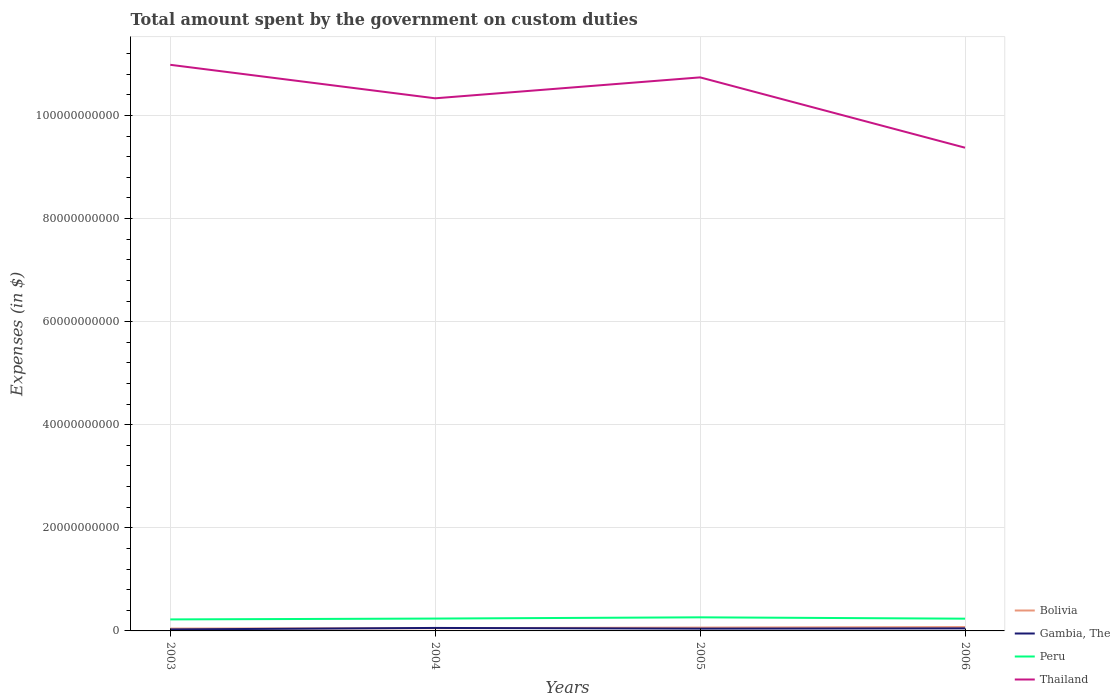How many different coloured lines are there?
Offer a very short reply. 4. Does the line corresponding to Thailand intersect with the line corresponding to Gambia, The?
Your answer should be compact. No. Is the number of lines equal to the number of legend labels?
Offer a terse response. Yes. Across all years, what is the maximum amount spent on custom duties by the government in Thailand?
Your response must be concise. 9.37e+1. In which year was the amount spent on custom duties by the government in Thailand maximum?
Offer a terse response. 2006. What is the total amount spent on custom duties by the government in Gambia, The in the graph?
Provide a succinct answer. -4.74e+07. What is the difference between the highest and the second highest amount spent on custom duties by the government in Gambia, The?
Offer a very short reply. 2.86e+08. What is the difference between the highest and the lowest amount spent on custom duties by the government in Peru?
Ensure brevity in your answer.  1. Where does the legend appear in the graph?
Your answer should be compact. Bottom right. What is the title of the graph?
Your response must be concise. Total amount spent by the government on custom duties. Does "Sub-Saharan Africa (developing only)" appear as one of the legend labels in the graph?
Offer a terse response. No. What is the label or title of the X-axis?
Keep it short and to the point. Years. What is the label or title of the Y-axis?
Give a very brief answer. Expenses (in $). What is the Expenses (in $) in Bolivia in 2003?
Your answer should be compact. 4.55e+08. What is the Expenses (in $) of Gambia, The in 2003?
Make the answer very short. 2.92e+08. What is the Expenses (in $) in Peru in 2003?
Keep it short and to the point. 2.23e+09. What is the Expenses (in $) in Thailand in 2003?
Give a very brief answer. 1.10e+11. What is the Expenses (in $) of Bolivia in 2004?
Keep it short and to the point. 5.28e+08. What is the Expenses (in $) in Gambia, The in 2004?
Offer a very short reply. 5.77e+08. What is the Expenses (in $) in Peru in 2004?
Ensure brevity in your answer.  2.40e+09. What is the Expenses (in $) of Thailand in 2004?
Your answer should be very brief. 1.03e+11. What is the Expenses (in $) in Bolivia in 2005?
Provide a succinct answer. 6.48e+08. What is the Expenses (in $) of Gambia, The in 2005?
Offer a very short reply. 4.43e+08. What is the Expenses (in $) in Peru in 2005?
Provide a short and direct response. 2.64e+09. What is the Expenses (in $) of Thailand in 2005?
Provide a succinct answer. 1.07e+11. What is the Expenses (in $) of Bolivia in 2006?
Your answer should be very brief. 7.50e+08. What is the Expenses (in $) in Gambia, The in 2006?
Your answer should be compact. 4.91e+08. What is the Expenses (in $) in Peru in 2006?
Your answer should be compact. 2.38e+09. What is the Expenses (in $) of Thailand in 2006?
Your answer should be very brief. 9.37e+1. Across all years, what is the maximum Expenses (in $) of Bolivia?
Offer a very short reply. 7.50e+08. Across all years, what is the maximum Expenses (in $) of Gambia, The?
Offer a terse response. 5.77e+08. Across all years, what is the maximum Expenses (in $) of Peru?
Your answer should be compact. 2.64e+09. Across all years, what is the maximum Expenses (in $) in Thailand?
Offer a terse response. 1.10e+11. Across all years, what is the minimum Expenses (in $) in Bolivia?
Give a very brief answer. 4.55e+08. Across all years, what is the minimum Expenses (in $) in Gambia, The?
Provide a succinct answer. 2.92e+08. Across all years, what is the minimum Expenses (in $) in Peru?
Offer a very short reply. 2.23e+09. Across all years, what is the minimum Expenses (in $) of Thailand?
Offer a terse response. 9.37e+1. What is the total Expenses (in $) in Bolivia in the graph?
Provide a succinct answer. 2.38e+09. What is the total Expenses (in $) of Gambia, The in the graph?
Make the answer very short. 1.80e+09. What is the total Expenses (in $) in Peru in the graph?
Provide a short and direct response. 9.65e+09. What is the total Expenses (in $) of Thailand in the graph?
Give a very brief answer. 4.14e+11. What is the difference between the Expenses (in $) of Bolivia in 2003 and that in 2004?
Make the answer very short. -7.31e+07. What is the difference between the Expenses (in $) of Gambia, The in 2003 and that in 2004?
Ensure brevity in your answer.  -2.86e+08. What is the difference between the Expenses (in $) of Peru in 2003 and that in 2004?
Your response must be concise. -1.65e+08. What is the difference between the Expenses (in $) in Thailand in 2003 and that in 2004?
Keep it short and to the point. 6.50e+09. What is the difference between the Expenses (in $) in Bolivia in 2003 and that in 2005?
Keep it short and to the point. -1.93e+08. What is the difference between the Expenses (in $) in Gambia, The in 2003 and that in 2005?
Make the answer very short. -1.52e+08. What is the difference between the Expenses (in $) of Peru in 2003 and that in 2005?
Your answer should be compact. -4.05e+08. What is the difference between the Expenses (in $) of Thailand in 2003 and that in 2005?
Offer a very short reply. 2.44e+09. What is the difference between the Expenses (in $) in Bolivia in 2003 and that in 2006?
Make the answer very short. -2.95e+08. What is the difference between the Expenses (in $) in Gambia, The in 2003 and that in 2006?
Make the answer very short. -1.99e+08. What is the difference between the Expenses (in $) of Peru in 2003 and that in 2006?
Provide a succinct answer. -1.43e+08. What is the difference between the Expenses (in $) in Thailand in 2003 and that in 2006?
Your response must be concise. 1.61e+1. What is the difference between the Expenses (in $) in Bolivia in 2004 and that in 2005?
Your answer should be very brief. -1.20e+08. What is the difference between the Expenses (in $) of Gambia, The in 2004 and that in 2005?
Your answer should be compact. 1.34e+08. What is the difference between the Expenses (in $) in Peru in 2004 and that in 2005?
Offer a very short reply. -2.41e+08. What is the difference between the Expenses (in $) of Thailand in 2004 and that in 2005?
Your response must be concise. -4.06e+09. What is the difference between the Expenses (in $) of Bolivia in 2004 and that in 2006?
Provide a short and direct response. -2.22e+08. What is the difference between the Expenses (in $) of Gambia, The in 2004 and that in 2006?
Provide a short and direct response. 8.66e+07. What is the difference between the Expenses (in $) in Peru in 2004 and that in 2006?
Provide a short and direct response. 2.15e+07. What is the difference between the Expenses (in $) of Thailand in 2004 and that in 2006?
Offer a terse response. 9.59e+09. What is the difference between the Expenses (in $) of Bolivia in 2005 and that in 2006?
Ensure brevity in your answer.  -1.02e+08. What is the difference between the Expenses (in $) in Gambia, The in 2005 and that in 2006?
Provide a succinct answer. -4.74e+07. What is the difference between the Expenses (in $) of Peru in 2005 and that in 2006?
Make the answer very short. 2.62e+08. What is the difference between the Expenses (in $) of Thailand in 2005 and that in 2006?
Make the answer very short. 1.36e+1. What is the difference between the Expenses (in $) in Bolivia in 2003 and the Expenses (in $) in Gambia, The in 2004?
Your response must be concise. -1.22e+08. What is the difference between the Expenses (in $) of Bolivia in 2003 and the Expenses (in $) of Peru in 2004?
Keep it short and to the point. -1.94e+09. What is the difference between the Expenses (in $) in Bolivia in 2003 and the Expenses (in $) in Thailand in 2004?
Ensure brevity in your answer.  -1.03e+11. What is the difference between the Expenses (in $) in Gambia, The in 2003 and the Expenses (in $) in Peru in 2004?
Provide a succinct answer. -2.11e+09. What is the difference between the Expenses (in $) in Gambia, The in 2003 and the Expenses (in $) in Thailand in 2004?
Provide a succinct answer. -1.03e+11. What is the difference between the Expenses (in $) of Peru in 2003 and the Expenses (in $) of Thailand in 2004?
Make the answer very short. -1.01e+11. What is the difference between the Expenses (in $) in Bolivia in 2003 and the Expenses (in $) in Gambia, The in 2005?
Your answer should be very brief. 1.18e+07. What is the difference between the Expenses (in $) of Bolivia in 2003 and the Expenses (in $) of Peru in 2005?
Ensure brevity in your answer.  -2.18e+09. What is the difference between the Expenses (in $) in Bolivia in 2003 and the Expenses (in $) in Thailand in 2005?
Offer a terse response. -1.07e+11. What is the difference between the Expenses (in $) in Gambia, The in 2003 and the Expenses (in $) in Peru in 2005?
Keep it short and to the point. -2.35e+09. What is the difference between the Expenses (in $) in Gambia, The in 2003 and the Expenses (in $) in Thailand in 2005?
Make the answer very short. -1.07e+11. What is the difference between the Expenses (in $) of Peru in 2003 and the Expenses (in $) of Thailand in 2005?
Offer a very short reply. -1.05e+11. What is the difference between the Expenses (in $) of Bolivia in 2003 and the Expenses (in $) of Gambia, The in 2006?
Make the answer very short. -3.56e+07. What is the difference between the Expenses (in $) in Bolivia in 2003 and the Expenses (in $) in Peru in 2006?
Make the answer very short. -1.92e+09. What is the difference between the Expenses (in $) of Bolivia in 2003 and the Expenses (in $) of Thailand in 2006?
Your answer should be compact. -9.33e+1. What is the difference between the Expenses (in $) in Gambia, The in 2003 and the Expenses (in $) in Peru in 2006?
Provide a succinct answer. -2.08e+09. What is the difference between the Expenses (in $) of Gambia, The in 2003 and the Expenses (in $) of Thailand in 2006?
Your answer should be very brief. -9.35e+1. What is the difference between the Expenses (in $) of Peru in 2003 and the Expenses (in $) of Thailand in 2006?
Make the answer very short. -9.15e+1. What is the difference between the Expenses (in $) of Bolivia in 2004 and the Expenses (in $) of Gambia, The in 2005?
Provide a succinct answer. 8.49e+07. What is the difference between the Expenses (in $) in Bolivia in 2004 and the Expenses (in $) in Peru in 2005?
Provide a short and direct response. -2.11e+09. What is the difference between the Expenses (in $) of Bolivia in 2004 and the Expenses (in $) of Thailand in 2005?
Your answer should be very brief. -1.07e+11. What is the difference between the Expenses (in $) of Gambia, The in 2004 and the Expenses (in $) of Peru in 2005?
Your response must be concise. -2.06e+09. What is the difference between the Expenses (in $) in Gambia, The in 2004 and the Expenses (in $) in Thailand in 2005?
Keep it short and to the point. -1.07e+11. What is the difference between the Expenses (in $) in Peru in 2004 and the Expenses (in $) in Thailand in 2005?
Keep it short and to the point. -1.05e+11. What is the difference between the Expenses (in $) in Bolivia in 2004 and the Expenses (in $) in Gambia, The in 2006?
Offer a terse response. 3.75e+07. What is the difference between the Expenses (in $) of Bolivia in 2004 and the Expenses (in $) of Peru in 2006?
Offer a very short reply. -1.85e+09. What is the difference between the Expenses (in $) in Bolivia in 2004 and the Expenses (in $) in Thailand in 2006?
Provide a short and direct response. -9.32e+1. What is the difference between the Expenses (in $) of Gambia, The in 2004 and the Expenses (in $) of Peru in 2006?
Make the answer very short. -1.80e+09. What is the difference between the Expenses (in $) in Gambia, The in 2004 and the Expenses (in $) in Thailand in 2006?
Keep it short and to the point. -9.32e+1. What is the difference between the Expenses (in $) in Peru in 2004 and the Expenses (in $) in Thailand in 2006?
Give a very brief answer. -9.14e+1. What is the difference between the Expenses (in $) in Bolivia in 2005 and the Expenses (in $) in Gambia, The in 2006?
Offer a terse response. 1.58e+08. What is the difference between the Expenses (in $) in Bolivia in 2005 and the Expenses (in $) in Peru in 2006?
Provide a succinct answer. -1.73e+09. What is the difference between the Expenses (in $) of Bolivia in 2005 and the Expenses (in $) of Thailand in 2006?
Make the answer very short. -9.31e+1. What is the difference between the Expenses (in $) of Gambia, The in 2005 and the Expenses (in $) of Peru in 2006?
Your answer should be compact. -1.93e+09. What is the difference between the Expenses (in $) in Gambia, The in 2005 and the Expenses (in $) in Thailand in 2006?
Offer a very short reply. -9.33e+1. What is the difference between the Expenses (in $) in Peru in 2005 and the Expenses (in $) in Thailand in 2006?
Offer a terse response. -9.11e+1. What is the average Expenses (in $) in Bolivia per year?
Give a very brief answer. 5.96e+08. What is the average Expenses (in $) of Gambia, The per year?
Keep it short and to the point. 4.51e+08. What is the average Expenses (in $) in Peru per year?
Give a very brief answer. 2.41e+09. What is the average Expenses (in $) of Thailand per year?
Your answer should be compact. 1.04e+11. In the year 2003, what is the difference between the Expenses (in $) of Bolivia and Expenses (in $) of Gambia, The?
Make the answer very short. 1.63e+08. In the year 2003, what is the difference between the Expenses (in $) of Bolivia and Expenses (in $) of Peru?
Make the answer very short. -1.78e+09. In the year 2003, what is the difference between the Expenses (in $) in Bolivia and Expenses (in $) in Thailand?
Your answer should be compact. -1.09e+11. In the year 2003, what is the difference between the Expenses (in $) in Gambia, The and Expenses (in $) in Peru?
Your answer should be compact. -1.94e+09. In the year 2003, what is the difference between the Expenses (in $) in Gambia, The and Expenses (in $) in Thailand?
Give a very brief answer. -1.10e+11. In the year 2003, what is the difference between the Expenses (in $) in Peru and Expenses (in $) in Thailand?
Your response must be concise. -1.08e+11. In the year 2004, what is the difference between the Expenses (in $) of Bolivia and Expenses (in $) of Gambia, The?
Your answer should be compact. -4.91e+07. In the year 2004, what is the difference between the Expenses (in $) in Bolivia and Expenses (in $) in Peru?
Provide a short and direct response. -1.87e+09. In the year 2004, what is the difference between the Expenses (in $) of Bolivia and Expenses (in $) of Thailand?
Ensure brevity in your answer.  -1.03e+11. In the year 2004, what is the difference between the Expenses (in $) in Gambia, The and Expenses (in $) in Peru?
Provide a short and direct response. -1.82e+09. In the year 2004, what is the difference between the Expenses (in $) of Gambia, The and Expenses (in $) of Thailand?
Keep it short and to the point. -1.03e+11. In the year 2004, what is the difference between the Expenses (in $) of Peru and Expenses (in $) of Thailand?
Offer a very short reply. -1.01e+11. In the year 2005, what is the difference between the Expenses (in $) in Bolivia and Expenses (in $) in Gambia, The?
Ensure brevity in your answer.  2.05e+08. In the year 2005, what is the difference between the Expenses (in $) of Bolivia and Expenses (in $) of Peru?
Give a very brief answer. -1.99e+09. In the year 2005, what is the difference between the Expenses (in $) in Bolivia and Expenses (in $) in Thailand?
Give a very brief answer. -1.07e+11. In the year 2005, what is the difference between the Expenses (in $) in Gambia, The and Expenses (in $) in Peru?
Ensure brevity in your answer.  -2.20e+09. In the year 2005, what is the difference between the Expenses (in $) in Gambia, The and Expenses (in $) in Thailand?
Offer a terse response. -1.07e+11. In the year 2005, what is the difference between the Expenses (in $) in Peru and Expenses (in $) in Thailand?
Your answer should be compact. -1.05e+11. In the year 2006, what is the difference between the Expenses (in $) of Bolivia and Expenses (in $) of Gambia, The?
Provide a short and direct response. 2.60e+08. In the year 2006, what is the difference between the Expenses (in $) in Bolivia and Expenses (in $) in Peru?
Your response must be concise. -1.63e+09. In the year 2006, what is the difference between the Expenses (in $) in Bolivia and Expenses (in $) in Thailand?
Your answer should be compact. -9.30e+1. In the year 2006, what is the difference between the Expenses (in $) in Gambia, The and Expenses (in $) in Peru?
Your answer should be very brief. -1.89e+09. In the year 2006, what is the difference between the Expenses (in $) of Gambia, The and Expenses (in $) of Thailand?
Make the answer very short. -9.33e+1. In the year 2006, what is the difference between the Expenses (in $) of Peru and Expenses (in $) of Thailand?
Ensure brevity in your answer.  -9.14e+1. What is the ratio of the Expenses (in $) in Bolivia in 2003 to that in 2004?
Offer a terse response. 0.86. What is the ratio of the Expenses (in $) in Gambia, The in 2003 to that in 2004?
Give a very brief answer. 0.51. What is the ratio of the Expenses (in $) of Peru in 2003 to that in 2004?
Keep it short and to the point. 0.93. What is the ratio of the Expenses (in $) in Thailand in 2003 to that in 2004?
Ensure brevity in your answer.  1.06. What is the ratio of the Expenses (in $) of Bolivia in 2003 to that in 2005?
Make the answer very short. 0.7. What is the ratio of the Expenses (in $) of Gambia, The in 2003 to that in 2005?
Your answer should be very brief. 0.66. What is the ratio of the Expenses (in $) of Peru in 2003 to that in 2005?
Give a very brief answer. 0.85. What is the ratio of the Expenses (in $) of Thailand in 2003 to that in 2005?
Provide a short and direct response. 1.02. What is the ratio of the Expenses (in $) of Bolivia in 2003 to that in 2006?
Your answer should be compact. 0.61. What is the ratio of the Expenses (in $) of Gambia, The in 2003 to that in 2006?
Ensure brevity in your answer.  0.59. What is the ratio of the Expenses (in $) in Peru in 2003 to that in 2006?
Ensure brevity in your answer.  0.94. What is the ratio of the Expenses (in $) of Thailand in 2003 to that in 2006?
Provide a succinct answer. 1.17. What is the ratio of the Expenses (in $) of Bolivia in 2004 to that in 2005?
Offer a terse response. 0.81. What is the ratio of the Expenses (in $) in Gambia, The in 2004 to that in 2005?
Ensure brevity in your answer.  1.3. What is the ratio of the Expenses (in $) of Peru in 2004 to that in 2005?
Offer a very short reply. 0.91. What is the ratio of the Expenses (in $) of Thailand in 2004 to that in 2005?
Provide a succinct answer. 0.96. What is the ratio of the Expenses (in $) in Bolivia in 2004 to that in 2006?
Provide a succinct answer. 0.7. What is the ratio of the Expenses (in $) in Gambia, The in 2004 to that in 2006?
Offer a terse response. 1.18. What is the ratio of the Expenses (in $) of Peru in 2004 to that in 2006?
Your answer should be very brief. 1.01. What is the ratio of the Expenses (in $) of Thailand in 2004 to that in 2006?
Make the answer very short. 1.1. What is the ratio of the Expenses (in $) of Bolivia in 2005 to that in 2006?
Your answer should be compact. 0.86. What is the ratio of the Expenses (in $) of Gambia, The in 2005 to that in 2006?
Provide a succinct answer. 0.9. What is the ratio of the Expenses (in $) in Peru in 2005 to that in 2006?
Provide a short and direct response. 1.11. What is the ratio of the Expenses (in $) in Thailand in 2005 to that in 2006?
Provide a succinct answer. 1.15. What is the difference between the highest and the second highest Expenses (in $) of Bolivia?
Your response must be concise. 1.02e+08. What is the difference between the highest and the second highest Expenses (in $) in Gambia, The?
Make the answer very short. 8.66e+07. What is the difference between the highest and the second highest Expenses (in $) of Peru?
Provide a short and direct response. 2.41e+08. What is the difference between the highest and the second highest Expenses (in $) in Thailand?
Provide a succinct answer. 2.44e+09. What is the difference between the highest and the lowest Expenses (in $) of Bolivia?
Keep it short and to the point. 2.95e+08. What is the difference between the highest and the lowest Expenses (in $) of Gambia, The?
Provide a short and direct response. 2.86e+08. What is the difference between the highest and the lowest Expenses (in $) in Peru?
Offer a very short reply. 4.05e+08. What is the difference between the highest and the lowest Expenses (in $) in Thailand?
Your response must be concise. 1.61e+1. 